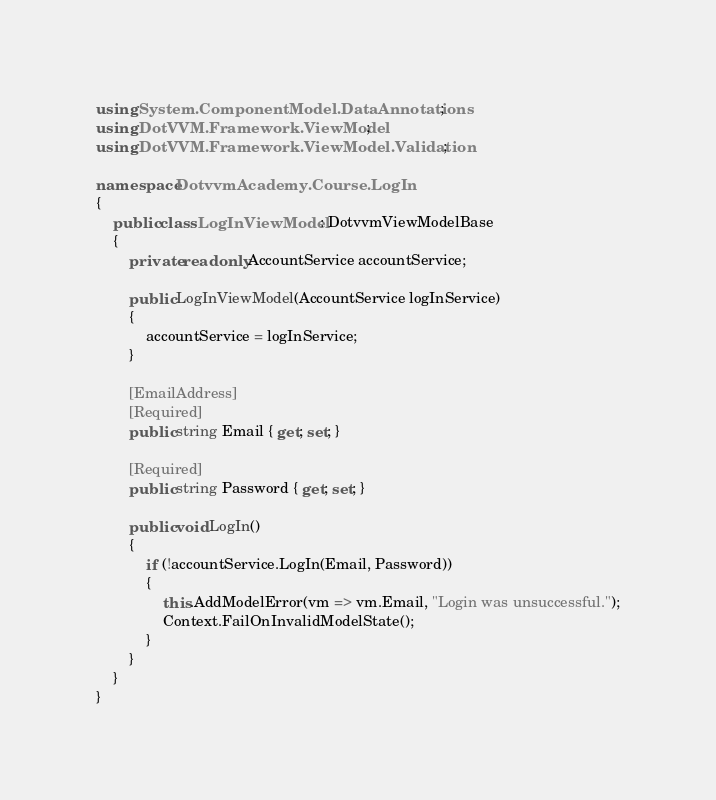Convert code to text. <code><loc_0><loc_0><loc_500><loc_500><_C#_>using System.ComponentModel.DataAnnotations;
using DotVVM.Framework.ViewModel;
using DotVVM.Framework.ViewModel.Validation;

namespace DotvvmAcademy.Course.LogIn
{
    public class LogInViewModel : DotvvmViewModelBase
    {
        private readonly AccountService accountService;

        public LogInViewModel(AccountService logInService)
        {
            accountService = logInService;
        }

        [EmailAddress]
        [Required]
        public string Email { get; set; }

        [Required]
        public string Password { get; set; }

        public void LogIn()
        {
            if (!accountService.LogIn(Email, Password))
            {
                this.AddModelError(vm => vm.Email, "Login was unsuccessful.");
                Context.FailOnInvalidModelState();
            }
        }
    }
}
</code> 